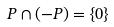Convert formula to latex. <formula><loc_0><loc_0><loc_500><loc_500>P \cap ( - P ) = \{ 0 \}</formula> 